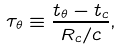<formula> <loc_0><loc_0><loc_500><loc_500>\tau _ { \theta } \equiv \frac { t _ { \theta } - t _ { c } } { R _ { c } / c } ,</formula> 